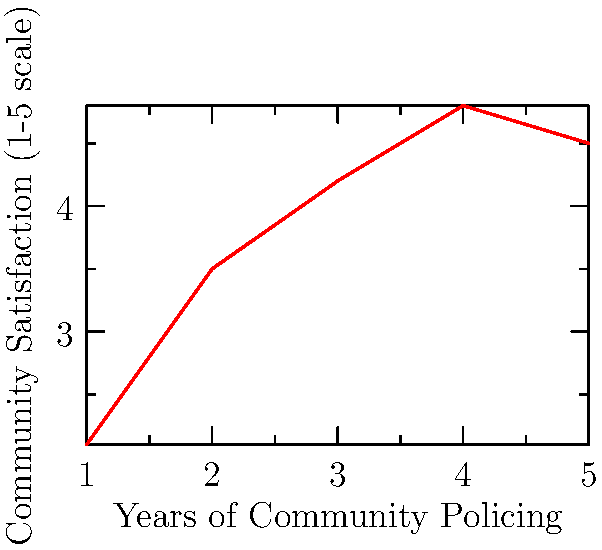Based on the coordinate system shown, which year of community policing implementation appears to have the highest level of community satisfaction with police interactions? To determine the year with the highest level of community satisfaction, we need to follow these steps:

1. Understand the axes:
   - X-axis represents Years of Community Policing (1 to 5)
   - Y-axis represents Community Satisfaction on a scale of 1 to 5

2. Identify the data points:
   - Year 1: (1, 2.1)
   - Year 2: (2, 3.5)
   - Year 3: (3, 4.2)
   - Year 4: (4, 4.8)
   - Year 5: (5, 4.5)

3. Compare the y-values (satisfaction levels):
   - Year 1: 2.1
   - Year 2: 3.5
   - Year 3: 4.2
   - Year 4: 4.8
   - Year 5: 4.5

4. Identify the highest y-value:
   The highest y-value is 4.8, corresponding to Year 4.

Therefore, the 4th year of community policing implementation appears to have the highest level of community satisfaction with police interactions.
Answer: Year 4 